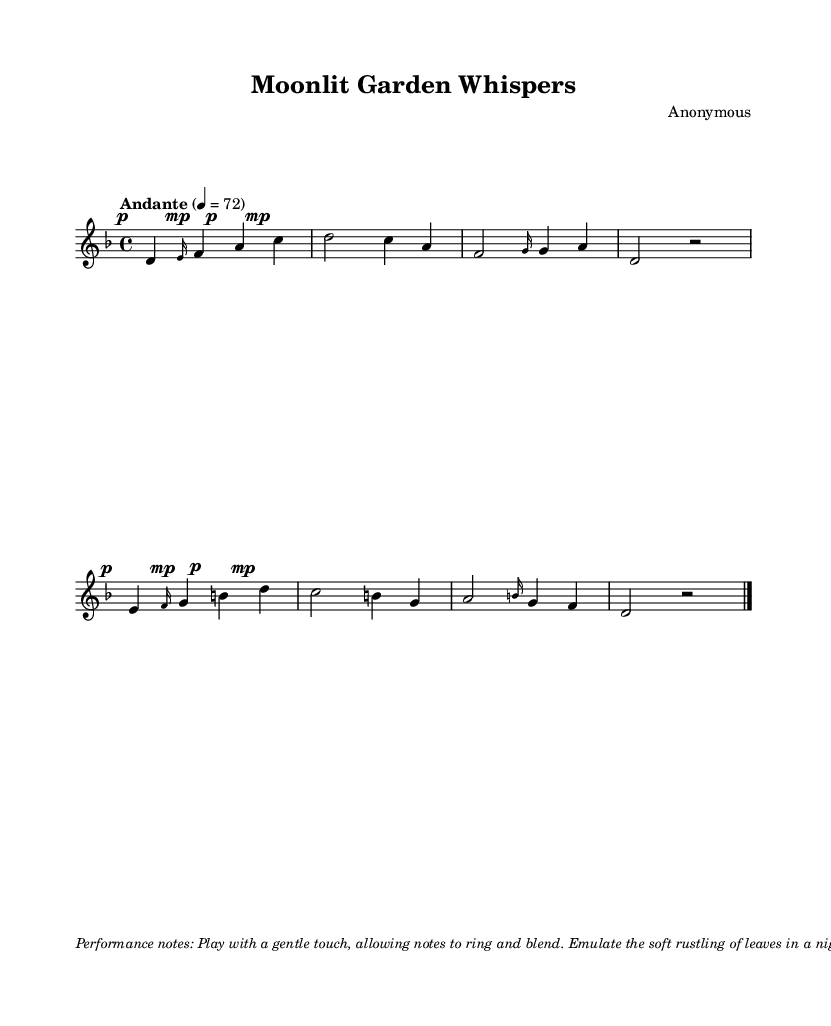What is the key signature of this music? The key signature is d minor, indicated by one flat which corresponds to the note B flat. You can see the key signature at the beginning of the staff right after the clef symbol.
Answer: d minor What is the time signature of this piece? The time signature is 4/4, found at the beginning of the music, indicating that there are four beats in a measure and each beat is a quarter note.
Answer: 4/4 What is the tempo marking for this music? The tempo marking is "Andante", which is usually interpreted as a moderate tempo, and is defined in the sheet above the music staff.
Answer: Andante How many measures are in the score? The score contains eight measures, counted visually by identifying each group of notes and rests separated by bar lines.
Answer: eight What is the dynamic marking at the beginning of the first measure? The dynamic marking is pianissimo, indicated by the “p” symbol written before the first note, suggesting to play softly.
Answer: pianissimo Which instrument typically plays this piece? The piece is typically played on the koto, a traditional Japanese string instrument, as the title suggests soothing melodies of this nature.
Answer: koto What mood does this music evoke? The music evokes a calming and peaceful mood which can be inferred from the gentle dynamics and the thematic focus on a moonlit garden.
Answer: calm 